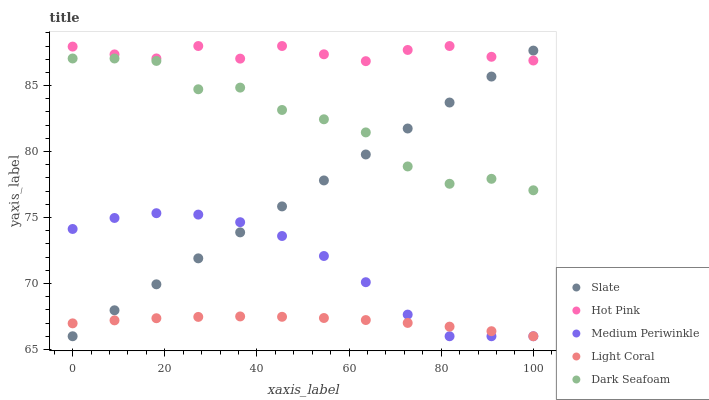Does Light Coral have the minimum area under the curve?
Answer yes or no. Yes. Does Hot Pink have the maximum area under the curve?
Answer yes or no. Yes. Does Slate have the minimum area under the curve?
Answer yes or no. No. Does Slate have the maximum area under the curve?
Answer yes or no. No. Is Slate the smoothest?
Answer yes or no. Yes. Is Dark Seafoam the roughest?
Answer yes or no. Yes. Is Hot Pink the smoothest?
Answer yes or no. No. Is Hot Pink the roughest?
Answer yes or no. No. Does Light Coral have the lowest value?
Answer yes or no. Yes. Does Hot Pink have the lowest value?
Answer yes or no. No. Does Hot Pink have the highest value?
Answer yes or no. Yes. Does Slate have the highest value?
Answer yes or no. No. Is Light Coral less than Dark Seafoam?
Answer yes or no. Yes. Is Hot Pink greater than Medium Periwinkle?
Answer yes or no. Yes. Does Slate intersect Light Coral?
Answer yes or no. Yes. Is Slate less than Light Coral?
Answer yes or no. No. Is Slate greater than Light Coral?
Answer yes or no. No. Does Light Coral intersect Dark Seafoam?
Answer yes or no. No. 